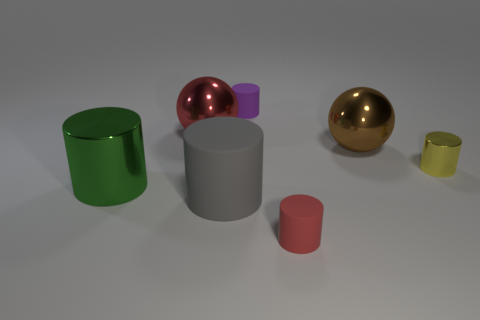Are any big purple rubber spheres visible?
Your answer should be very brief. No. Are there any large brown shiny objects behind the matte cylinder that is behind the big green object?
Provide a short and direct response. No. There is a gray thing that is the same shape as the tiny red matte thing; what is its material?
Ensure brevity in your answer.  Rubber. Are there more red objects than small objects?
Provide a short and direct response. No. What is the color of the object that is behind the brown metal object and to the left of the gray matte thing?
Offer a very short reply. Red. What number of other objects are the same material as the green object?
Ensure brevity in your answer.  3. Is the number of big brown metal balls less than the number of blue cylinders?
Provide a succinct answer. No. Do the tiny red cylinder and the gray cylinder left of the small purple rubber cylinder have the same material?
Provide a short and direct response. Yes. The small purple rubber thing that is behind the red metallic thing has what shape?
Your response must be concise. Cylinder. Are there fewer cylinders on the right side of the big green metallic cylinder than cylinders?
Keep it short and to the point. Yes. 